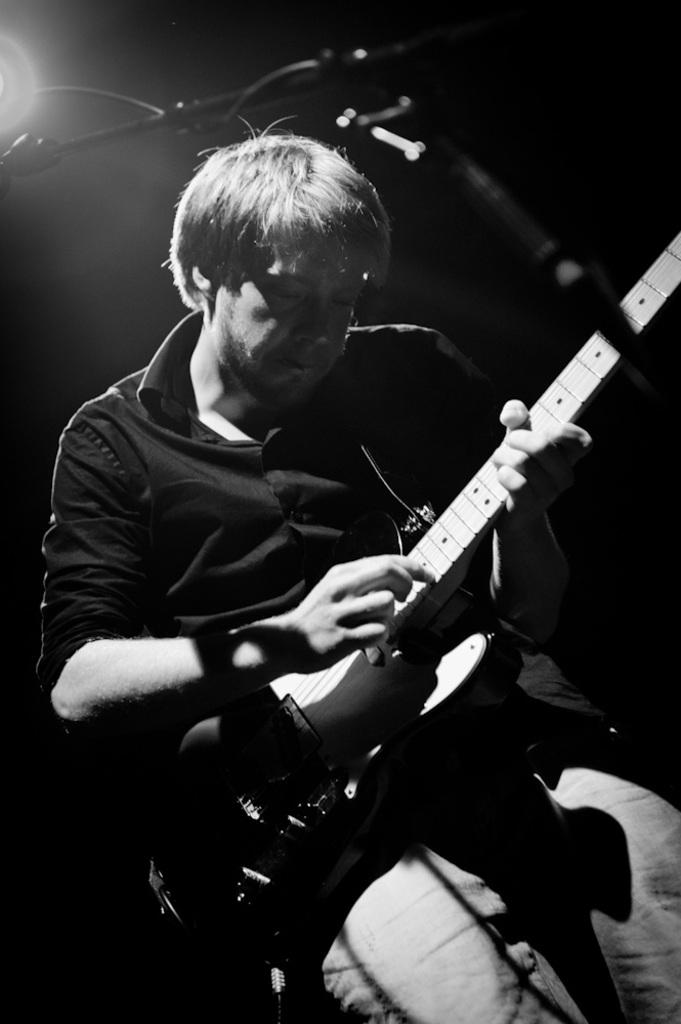Who is the person in the image? There is a man in the image. What is the man doing in the image? The man is playing a guitar. What object is in front of the man? There is a microphone in front of the man. What can be seen in the background of the image? There is a light visible in the background. How many pages of sheet music is the man holding while playing the guitar? The image does not show the man holding any sheet music, so it is not possible to determine the number of pages. 